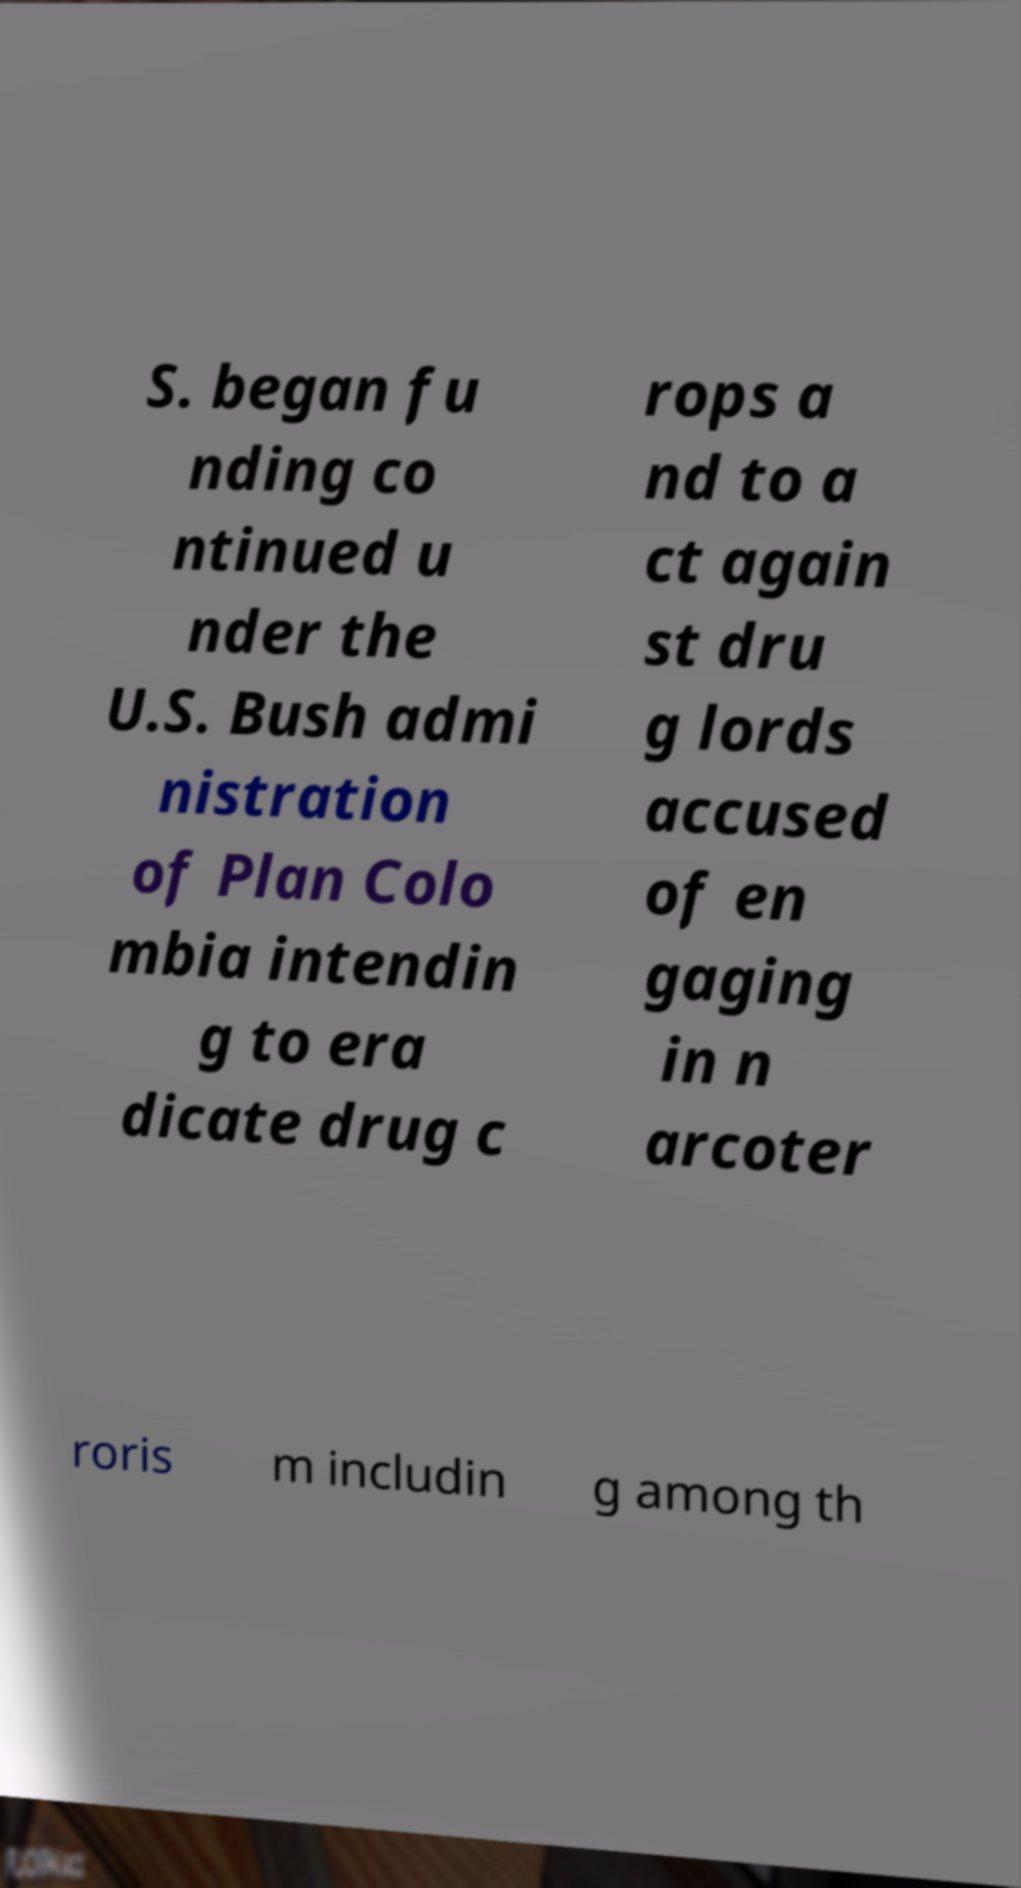Can you read and provide the text displayed in the image?This photo seems to have some interesting text. Can you extract and type it out for me? S. began fu nding co ntinued u nder the U.S. Bush admi nistration of Plan Colo mbia intendin g to era dicate drug c rops a nd to a ct again st dru g lords accused of en gaging in n arcoter roris m includin g among th 